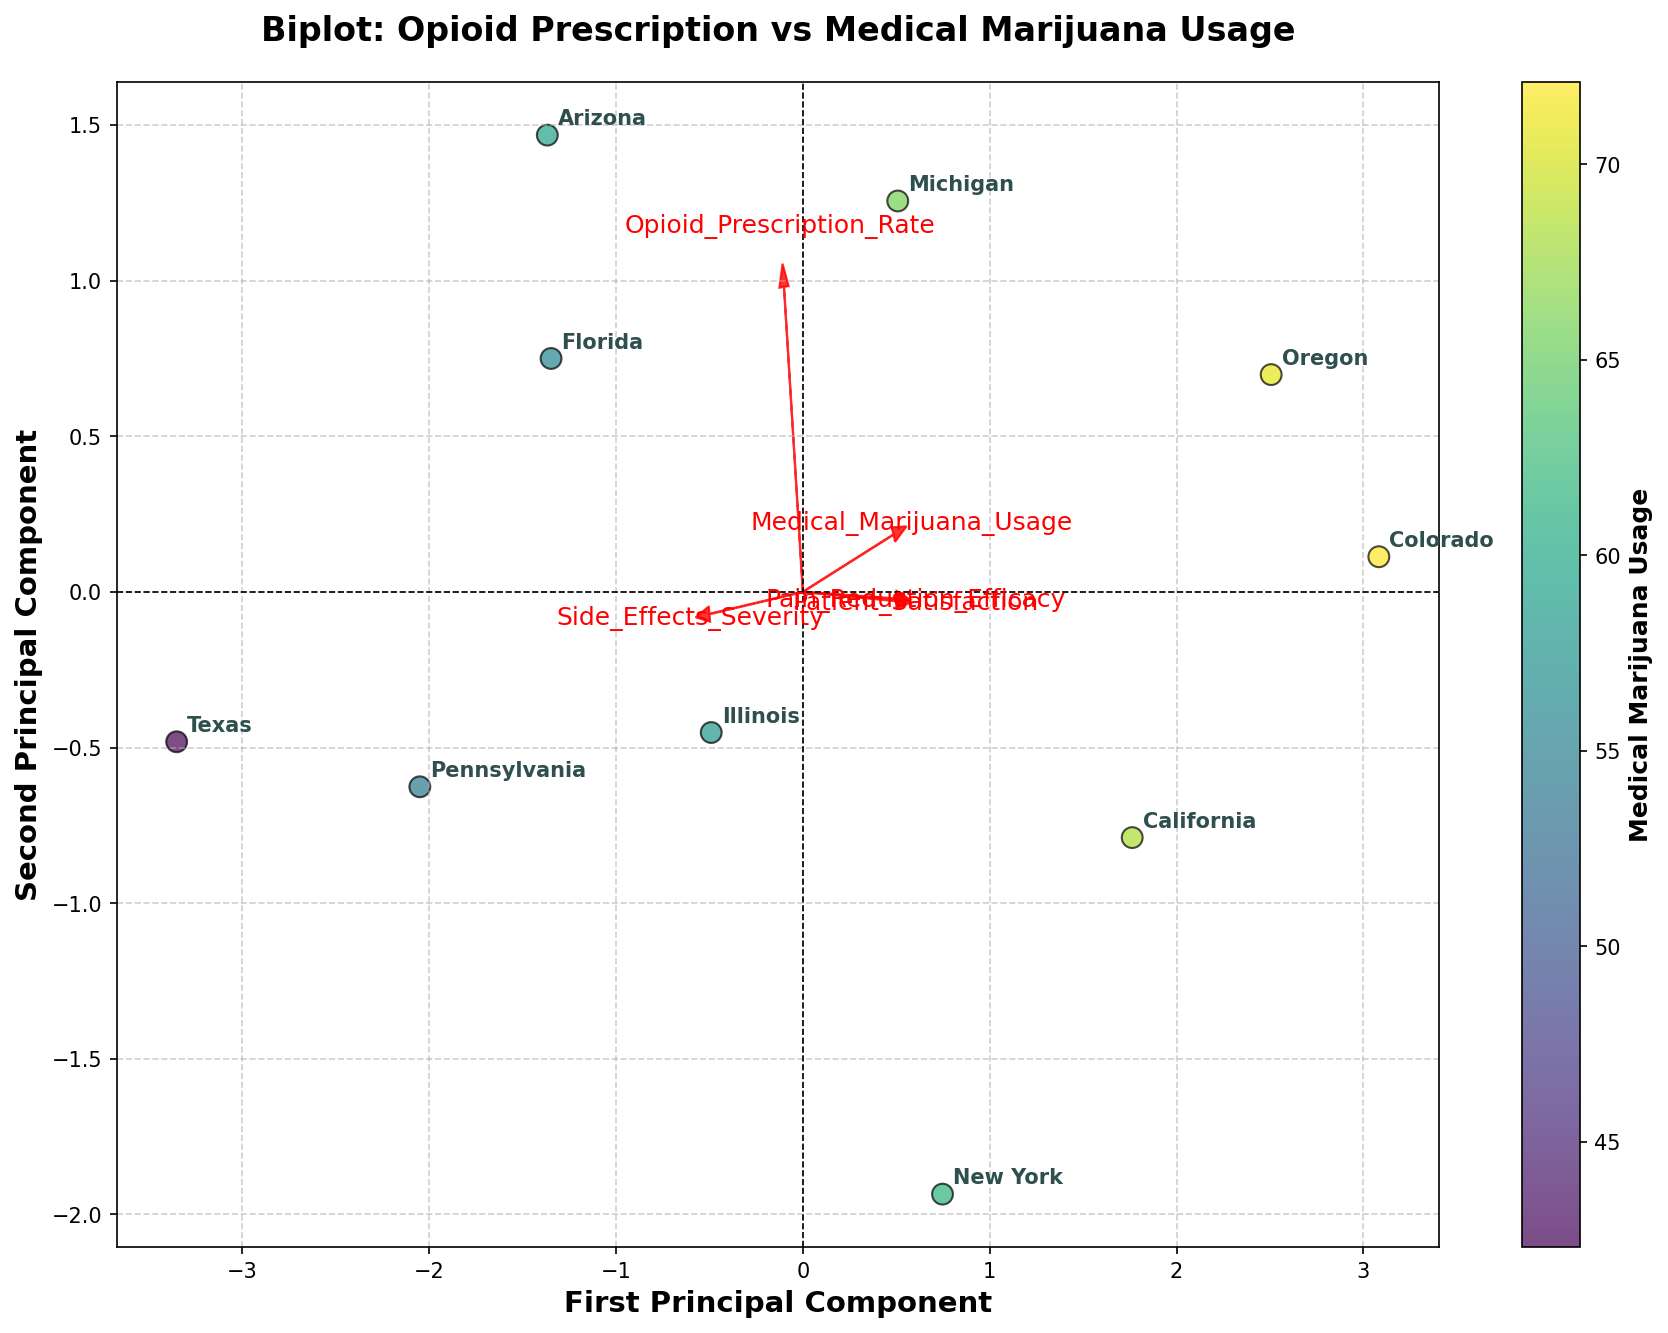what is the title of the plot? The title is placed at the top center of the plot and it reads 'Biplot: Opioid Prescription vs Medical Marijuana Usage'.
Answer: Biplot: Opioid Prescription vs Medical Marijuana Usage How many states are represented in the biplot? Each data point corresponds to a state, and we can count the labels provided. By counting the labels, we find that there are 10 states.
Answer: 10 Which state has the highest Medical Marijuana Usage? The color intensity of the data points represents Medical Marijuana Usage, with higher usage indicated by darker colors. Arizona seems to have the darkest shade.
Answer: Colorado Which state has the lowest Opioid Prescription Rate? The positioning of the data points along the components can help identify this. The first principal component predominantly aligns with Opioid Prescription Rate, and the data point farthest to the left corresponds to the lowest value, which is New York.
Answer: New York How are Pain Reduction Efficacy and Patient Satisfaction represented in the plot? These variables are represented by red arrows pointing from the origin. The direction and length of the arrows denote their contribution and correlation with the principal components. Both Pain Reduction Efficacy and Patient Satisfaction arrows point to the right and upward, indicating a positive correlation with both principal components.
Answer: By red arrows pointing from the origin What's the general trend between Opioid Prescription Rate and Medical Marijuana Usage among the states? By observing the scatter plot, states with higher Medical Marijuana Usage tend to have varied Opioid Prescription Rates; however, states with the highest Opioid Prescription Rates do not necessarily have the highest Medical Marijuana Usage.
Answer: Varied correlation How do California and Florida compare in terms of side effects severity? Looking at the alignment of data points and the corresponding red arrow labeled 'Side_Effects_Severity', we can see California is located farther left (implying lower severity) compared to Florida.
Answer: California has lower side effects severity Which state has the highest patient satisfaction? The red arrow 'Patient_Satisfaction' can be used to identify this; the state closest to the direction of this arrow (top right) is Colorado.
Answer: Colorado Based on the biplot, which variable appears to be most closely aligned with the first principal component? Observing the orientation of the red feature arrows, 'Opioid_Prescription_Rate' seems to be most closely aligned with the first principal component (horizontal axis).
Answer: Opioid Prescription Rate 